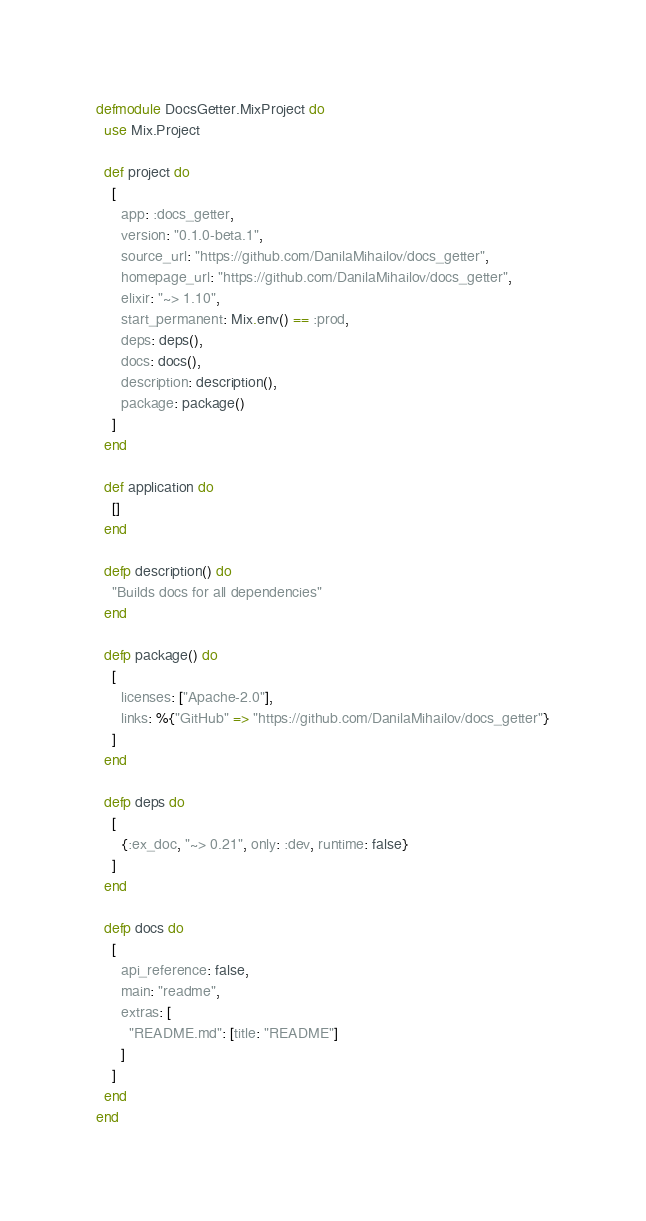Convert code to text. <code><loc_0><loc_0><loc_500><loc_500><_Elixir_>defmodule DocsGetter.MixProject do
  use Mix.Project

  def project do
    [
      app: :docs_getter,
      version: "0.1.0-beta.1",
      source_url: "https://github.com/DanilaMihailov/docs_getter",
      homepage_url: "https://github.com/DanilaMihailov/docs_getter",
      elixir: "~> 1.10",
      start_permanent: Mix.env() == :prod,
      deps: deps(),
      docs: docs(),
      description: description(),
      package: package()
    ]
  end

  def application do
    []
  end

  defp description() do
    "Builds docs for all dependencies"
  end

  defp package() do
    [
      licenses: ["Apache-2.0"],
      links: %{"GitHub" => "https://github.com/DanilaMihailov/docs_getter"}
    ]
  end

  defp deps do
    [
      {:ex_doc, "~> 0.21", only: :dev, runtime: false}
    ]
  end

  defp docs do
    [
      api_reference: false,
      main: "readme",
      extras: [
        "README.md": [title: "README"]
      ]
    ]
  end
end
</code> 